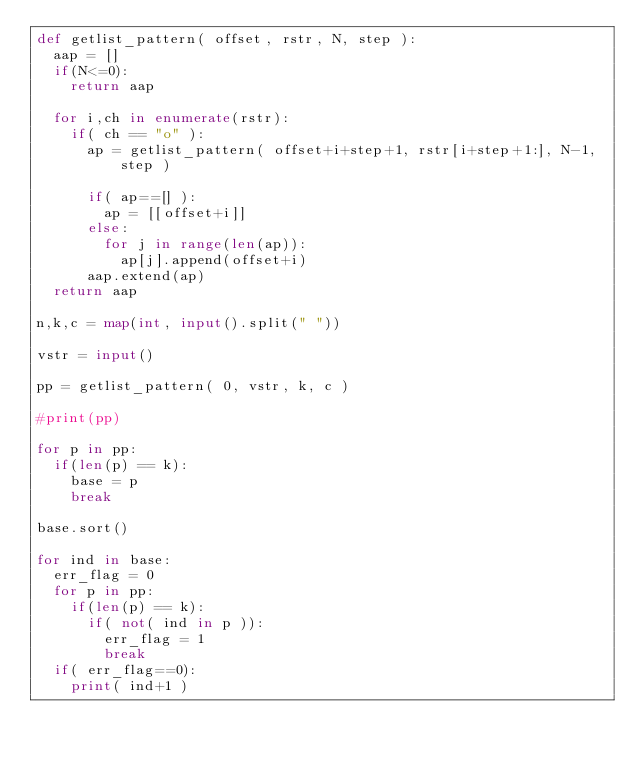Convert code to text. <code><loc_0><loc_0><loc_500><loc_500><_Python_>def getlist_pattern( offset, rstr, N, step ):
  aap = []
  if(N<=0):
    return aap
  
  for i,ch in enumerate(rstr):
    if( ch == "o" ):
      ap = getlist_pattern( offset+i+step+1, rstr[i+step+1:], N-1,step )
      
      if( ap==[] ):
        ap = [[offset+i]]
      else:
      	for j in range(len(ap)):
          ap[j].append(offset+i)
      aap.extend(ap)
  return aap    

n,k,c = map(int, input().split(" "))

vstr = input()

pp = getlist_pattern( 0, vstr, k, c )

#print(pp)

for p in pp:
  if(len(p) == k):
    base = p
    break

base.sort()

for ind in base:
  err_flag = 0
  for p in pp:
    if(len(p) == k):
      if( not( ind in p )):
        err_flag = 1
        break
  if( err_flag==0):
  	print( ind+1 )


    </code> 